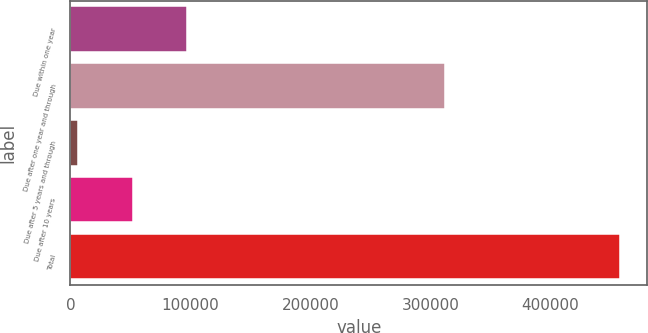Convert chart to OTSL. <chart><loc_0><loc_0><loc_500><loc_500><bar_chart><fcel>Due within one year<fcel>Due after one year and through<fcel>Due after 5 years and through<fcel>Due after 10 years<fcel>Total<nl><fcel>96900.6<fcel>312096<fcel>6679<fcel>51789.8<fcel>457787<nl></chart> 